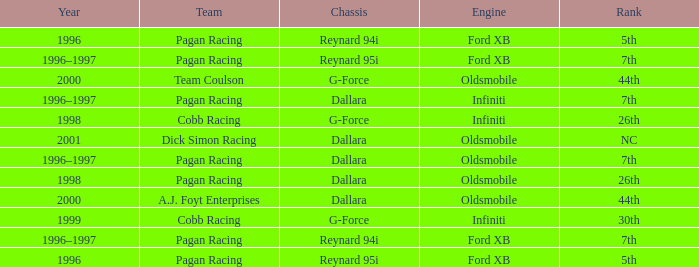What rank did the chassis reynard 94i have in 1996? 5th. 